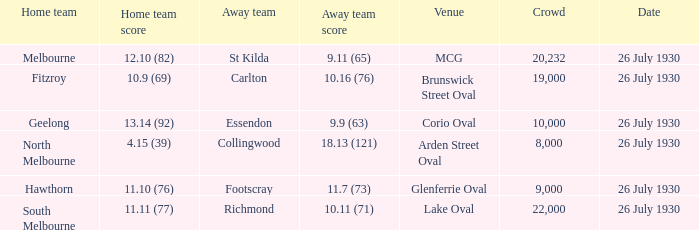When was Fitzroy the home team? 26 July 1930. 